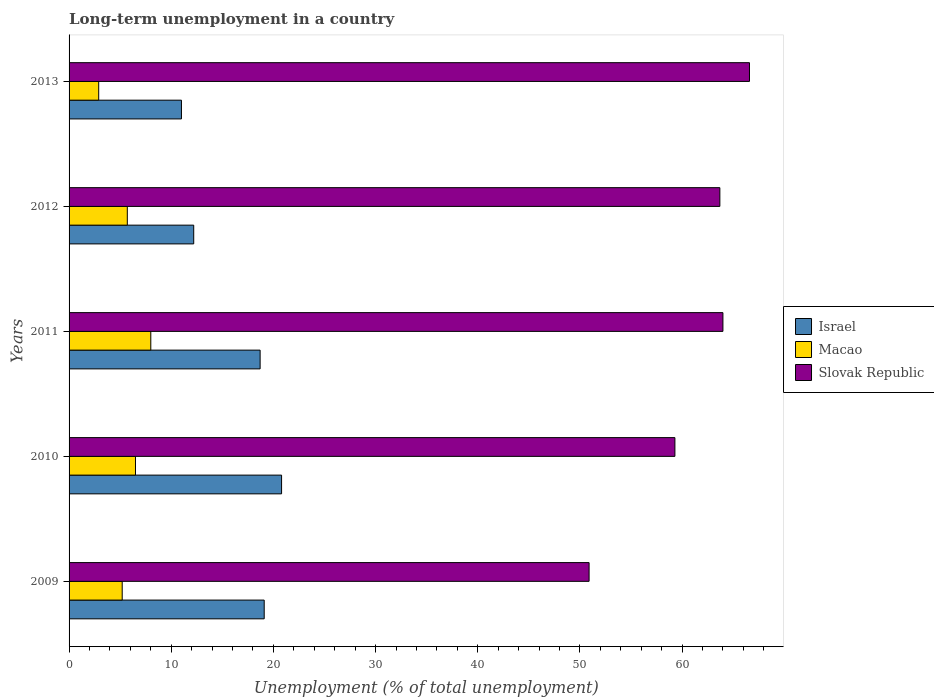How many different coloured bars are there?
Provide a succinct answer. 3. Are the number of bars per tick equal to the number of legend labels?
Your response must be concise. Yes. How many bars are there on the 3rd tick from the top?
Provide a succinct answer. 3. What is the label of the 4th group of bars from the top?
Your response must be concise. 2010. In how many cases, is the number of bars for a given year not equal to the number of legend labels?
Provide a succinct answer. 0. What is the percentage of long-term unemployed population in Israel in 2010?
Ensure brevity in your answer.  20.8. Across all years, what is the minimum percentage of long-term unemployed population in Macao?
Provide a short and direct response. 2.9. In which year was the percentage of long-term unemployed population in Slovak Republic maximum?
Give a very brief answer. 2013. In which year was the percentage of long-term unemployed population in Slovak Republic minimum?
Your answer should be very brief. 2009. What is the total percentage of long-term unemployed population in Slovak Republic in the graph?
Offer a very short reply. 304.5. What is the difference between the percentage of long-term unemployed population in Macao in 2010 and that in 2012?
Keep it short and to the point. 0.8. What is the difference between the percentage of long-term unemployed population in Macao in 2009 and the percentage of long-term unemployed population in Slovak Republic in 2013?
Your answer should be very brief. -61.4. What is the average percentage of long-term unemployed population in Macao per year?
Provide a succinct answer. 5.66. In the year 2012, what is the difference between the percentage of long-term unemployed population in Israel and percentage of long-term unemployed population in Macao?
Your response must be concise. 6.5. What is the ratio of the percentage of long-term unemployed population in Israel in 2011 to that in 2012?
Make the answer very short. 1.53. What is the difference between the highest and the second highest percentage of long-term unemployed population in Israel?
Offer a terse response. 1.7. What is the difference between the highest and the lowest percentage of long-term unemployed population in Slovak Republic?
Your response must be concise. 15.7. In how many years, is the percentage of long-term unemployed population in Slovak Republic greater than the average percentage of long-term unemployed population in Slovak Republic taken over all years?
Keep it short and to the point. 3. What does the 3rd bar from the bottom in 2012 represents?
Offer a terse response. Slovak Republic. Is it the case that in every year, the sum of the percentage of long-term unemployed population in Slovak Republic and percentage of long-term unemployed population in Israel is greater than the percentage of long-term unemployed population in Macao?
Ensure brevity in your answer.  Yes. Are all the bars in the graph horizontal?
Your answer should be compact. Yes. How many years are there in the graph?
Your answer should be very brief. 5. Does the graph contain any zero values?
Keep it short and to the point. No. Where does the legend appear in the graph?
Provide a short and direct response. Center right. How many legend labels are there?
Give a very brief answer. 3. What is the title of the graph?
Your answer should be very brief. Long-term unemployment in a country. Does "Czech Republic" appear as one of the legend labels in the graph?
Offer a very short reply. No. What is the label or title of the X-axis?
Provide a succinct answer. Unemployment (% of total unemployment). What is the label or title of the Y-axis?
Your response must be concise. Years. What is the Unemployment (% of total unemployment) in Israel in 2009?
Offer a very short reply. 19.1. What is the Unemployment (% of total unemployment) of Macao in 2009?
Your response must be concise. 5.2. What is the Unemployment (% of total unemployment) of Slovak Republic in 2009?
Offer a very short reply. 50.9. What is the Unemployment (% of total unemployment) in Israel in 2010?
Keep it short and to the point. 20.8. What is the Unemployment (% of total unemployment) in Slovak Republic in 2010?
Provide a short and direct response. 59.3. What is the Unemployment (% of total unemployment) in Israel in 2011?
Keep it short and to the point. 18.7. What is the Unemployment (% of total unemployment) in Macao in 2011?
Keep it short and to the point. 8. What is the Unemployment (% of total unemployment) of Slovak Republic in 2011?
Give a very brief answer. 64. What is the Unemployment (% of total unemployment) of Israel in 2012?
Your response must be concise. 12.2. What is the Unemployment (% of total unemployment) in Macao in 2012?
Provide a short and direct response. 5.7. What is the Unemployment (% of total unemployment) in Slovak Republic in 2012?
Keep it short and to the point. 63.7. What is the Unemployment (% of total unemployment) of Macao in 2013?
Keep it short and to the point. 2.9. What is the Unemployment (% of total unemployment) of Slovak Republic in 2013?
Make the answer very short. 66.6. Across all years, what is the maximum Unemployment (% of total unemployment) in Israel?
Provide a short and direct response. 20.8. Across all years, what is the maximum Unemployment (% of total unemployment) in Macao?
Provide a succinct answer. 8. Across all years, what is the maximum Unemployment (% of total unemployment) of Slovak Republic?
Offer a very short reply. 66.6. Across all years, what is the minimum Unemployment (% of total unemployment) of Macao?
Give a very brief answer. 2.9. Across all years, what is the minimum Unemployment (% of total unemployment) of Slovak Republic?
Ensure brevity in your answer.  50.9. What is the total Unemployment (% of total unemployment) of Israel in the graph?
Your answer should be very brief. 81.8. What is the total Unemployment (% of total unemployment) in Macao in the graph?
Offer a terse response. 28.3. What is the total Unemployment (% of total unemployment) of Slovak Republic in the graph?
Ensure brevity in your answer.  304.5. What is the difference between the Unemployment (% of total unemployment) of Macao in 2009 and that in 2010?
Ensure brevity in your answer.  -1.3. What is the difference between the Unemployment (% of total unemployment) in Slovak Republic in 2009 and that in 2010?
Ensure brevity in your answer.  -8.4. What is the difference between the Unemployment (% of total unemployment) in Macao in 2009 and that in 2011?
Keep it short and to the point. -2.8. What is the difference between the Unemployment (% of total unemployment) in Slovak Republic in 2009 and that in 2011?
Offer a terse response. -13.1. What is the difference between the Unemployment (% of total unemployment) in Israel in 2009 and that in 2012?
Provide a short and direct response. 6.9. What is the difference between the Unemployment (% of total unemployment) in Macao in 2009 and that in 2013?
Give a very brief answer. 2.3. What is the difference between the Unemployment (% of total unemployment) in Slovak Republic in 2009 and that in 2013?
Offer a terse response. -15.7. What is the difference between the Unemployment (% of total unemployment) in Macao in 2010 and that in 2011?
Make the answer very short. -1.5. What is the difference between the Unemployment (% of total unemployment) of Slovak Republic in 2010 and that in 2011?
Provide a short and direct response. -4.7. What is the difference between the Unemployment (% of total unemployment) of Slovak Republic in 2010 and that in 2012?
Keep it short and to the point. -4.4. What is the difference between the Unemployment (% of total unemployment) of Israel in 2011 and that in 2012?
Ensure brevity in your answer.  6.5. What is the difference between the Unemployment (% of total unemployment) of Israel in 2011 and that in 2013?
Give a very brief answer. 7.7. What is the difference between the Unemployment (% of total unemployment) in Macao in 2011 and that in 2013?
Offer a very short reply. 5.1. What is the difference between the Unemployment (% of total unemployment) of Slovak Republic in 2012 and that in 2013?
Offer a very short reply. -2.9. What is the difference between the Unemployment (% of total unemployment) in Israel in 2009 and the Unemployment (% of total unemployment) in Macao in 2010?
Provide a succinct answer. 12.6. What is the difference between the Unemployment (% of total unemployment) in Israel in 2009 and the Unemployment (% of total unemployment) in Slovak Republic in 2010?
Give a very brief answer. -40.2. What is the difference between the Unemployment (% of total unemployment) of Macao in 2009 and the Unemployment (% of total unemployment) of Slovak Republic in 2010?
Provide a succinct answer. -54.1. What is the difference between the Unemployment (% of total unemployment) of Israel in 2009 and the Unemployment (% of total unemployment) of Slovak Republic in 2011?
Offer a terse response. -44.9. What is the difference between the Unemployment (% of total unemployment) of Macao in 2009 and the Unemployment (% of total unemployment) of Slovak Republic in 2011?
Provide a succinct answer. -58.8. What is the difference between the Unemployment (% of total unemployment) in Israel in 2009 and the Unemployment (% of total unemployment) in Slovak Republic in 2012?
Give a very brief answer. -44.6. What is the difference between the Unemployment (% of total unemployment) in Macao in 2009 and the Unemployment (% of total unemployment) in Slovak Republic in 2012?
Your response must be concise. -58.5. What is the difference between the Unemployment (% of total unemployment) of Israel in 2009 and the Unemployment (% of total unemployment) of Macao in 2013?
Provide a short and direct response. 16.2. What is the difference between the Unemployment (% of total unemployment) in Israel in 2009 and the Unemployment (% of total unemployment) in Slovak Republic in 2013?
Provide a short and direct response. -47.5. What is the difference between the Unemployment (% of total unemployment) in Macao in 2009 and the Unemployment (% of total unemployment) in Slovak Republic in 2013?
Provide a short and direct response. -61.4. What is the difference between the Unemployment (% of total unemployment) of Israel in 2010 and the Unemployment (% of total unemployment) of Slovak Republic in 2011?
Ensure brevity in your answer.  -43.2. What is the difference between the Unemployment (% of total unemployment) in Macao in 2010 and the Unemployment (% of total unemployment) in Slovak Republic in 2011?
Provide a short and direct response. -57.5. What is the difference between the Unemployment (% of total unemployment) of Israel in 2010 and the Unemployment (% of total unemployment) of Slovak Republic in 2012?
Give a very brief answer. -42.9. What is the difference between the Unemployment (% of total unemployment) in Macao in 2010 and the Unemployment (% of total unemployment) in Slovak Republic in 2012?
Offer a terse response. -57.2. What is the difference between the Unemployment (% of total unemployment) of Israel in 2010 and the Unemployment (% of total unemployment) of Slovak Republic in 2013?
Ensure brevity in your answer.  -45.8. What is the difference between the Unemployment (% of total unemployment) of Macao in 2010 and the Unemployment (% of total unemployment) of Slovak Republic in 2013?
Offer a terse response. -60.1. What is the difference between the Unemployment (% of total unemployment) of Israel in 2011 and the Unemployment (% of total unemployment) of Slovak Republic in 2012?
Make the answer very short. -45. What is the difference between the Unemployment (% of total unemployment) in Macao in 2011 and the Unemployment (% of total unemployment) in Slovak Republic in 2012?
Provide a short and direct response. -55.7. What is the difference between the Unemployment (% of total unemployment) of Israel in 2011 and the Unemployment (% of total unemployment) of Macao in 2013?
Give a very brief answer. 15.8. What is the difference between the Unemployment (% of total unemployment) of Israel in 2011 and the Unemployment (% of total unemployment) of Slovak Republic in 2013?
Provide a succinct answer. -47.9. What is the difference between the Unemployment (% of total unemployment) in Macao in 2011 and the Unemployment (% of total unemployment) in Slovak Republic in 2013?
Provide a short and direct response. -58.6. What is the difference between the Unemployment (% of total unemployment) of Israel in 2012 and the Unemployment (% of total unemployment) of Macao in 2013?
Your answer should be very brief. 9.3. What is the difference between the Unemployment (% of total unemployment) in Israel in 2012 and the Unemployment (% of total unemployment) in Slovak Republic in 2013?
Offer a very short reply. -54.4. What is the difference between the Unemployment (% of total unemployment) in Macao in 2012 and the Unemployment (% of total unemployment) in Slovak Republic in 2013?
Provide a succinct answer. -60.9. What is the average Unemployment (% of total unemployment) of Israel per year?
Your answer should be compact. 16.36. What is the average Unemployment (% of total unemployment) of Macao per year?
Offer a very short reply. 5.66. What is the average Unemployment (% of total unemployment) in Slovak Republic per year?
Offer a very short reply. 60.9. In the year 2009, what is the difference between the Unemployment (% of total unemployment) of Israel and Unemployment (% of total unemployment) of Slovak Republic?
Your answer should be very brief. -31.8. In the year 2009, what is the difference between the Unemployment (% of total unemployment) in Macao and Unemployment (% of total unemployment) in Slovak Republic?
Give a very brief answer. -45.7. In the year 2010, what is the difference between the Unemployment (% of total unemployment) in Israel and Unemployment (% of total unemployment) in Slovak Republic?
Ensure brevity in your answer.  -38.5. In the year 2010, what is the difference between the Unemployment (% of total unemployment) of Macao and Unemployment (% of total unemployment) of Slovak Republic?
Offer a very short reply. -52.8. In the year 2011, what is the difference between the Unemployment (% of total unemployment) in Israel and Unemployment (% of total unemployment) in Macao?
Your answer should be compact. 10.7. In the year 2011, what is the difference between the Unemployment (% of total unemployment) of Israel and Unemployment (% of total unemployment) of Slovak Republic?
Keep it short and to the point. -45.3. In the year 2011, what is the difference between the Unemployment (% of total unemployment) in Macao and Unemployment (% of total unemployment) in Slovak Republic?
Keep it short and to the point. -56. In the year 2012, what is the difference between the Unemployment (% of total unemployment) in Israel and Unemployment (% of total unemployment) in Macao?
Offer a terse response. 6.5. In the year 2012, what is the difference between the Unemployment (% of total unemployment) in Israel and Unemployment (% of total unemployment) in Slovak Republic?
Make the answer very short. -51.5. In the year 2012, what is the difference between the Unemployment (% of total unemployment) of Macao and Unemployment (% of total unemployment) of Slovak Republic?
Provide a succinct answer. -58. In the year 2013, what is the difference between the Unemployment (% of total unemployment) of Israel and Unemployment (% of total unemployment) of Macao?
Provide a succinct answer. 8.1. In the year 2013, what is the difference between the Unemployment (% of total unemployment) in Israel and Unemployment (% of total unemployment) in Slovak Republic?
Make the answer very short. -55.6. In the year 2013, what is the difference between the Unemployment (% of total unemployment) of Macao and Unemployment (% of total unemployment) of Slovak Republic?
Your response must be concise. -63.7. What is the ratio of the Unemployment (% of total unemployment) in Israel in 2009 to that in 2010?
Offer a very short reply. 0.92. What is the ratio of the Unemployment (% of total unemployment) of Macao in 2009 to that in 2010?
Ensure brevity in your answer.  0.8. What is the ratio of the Unemployment (% of total unemployment) in Slovak Republic in 2009 to that in 2010?
Provide a short and direct response. 0.86. What is the ratio of the Unemployment (% of total unemployment) in Israel in 2009 to that in 2011?
Your answer should be compact. 1.02. What is the ratio of the Unemployment (% of total unemployment) in Macao in 2009 to that in 2011?
Your answer should be very brief. 0.65. What is the ratio of the Unemployment (% of total unemployment) in Slovak Republic in 2009 to that in 2011?
Ensure brevity in your answer.  0.8. What is the ratio of the Unemployment (% of total unemployment) in Israel in 2009 to that in 2012?
Make the answer very short. 1.57. What is the ratio of the Unemployment (% of total unemployment) of Macao in 2009 to that in 2012?
Provide a succinct answer. 0.91. What is the ratio of the Unemployment (% of total unemployment) of Slovak Republic in 2009 to that in 2012?
Provide a short and direct response. 0.8. What is the ratio of the Unemployment (% of total unemployment) of Israel in 2009 to that in 2013?
Make the answer very short. 1.74. What is the ratio of the Unemployment (% of total unemployment) of Macao in 2009 to that in 2013?
Your response must be concise. 1.79. What is the ratio of the Unemployment (% of total unemployment) of Slovak Republic in 2009 to that in 2013?
Give a very brief answer. 0.76. What is the ratio of the Unemployment (% of total unemployment) in Israel in 2010 to that in 2011?
Your answer should be very brief. 1.11. What is the ratio of the Unemployment (% of total unemployment) in Macao in 2010 to that in 2011?
Your response must be concise. 0.81. What is the ratio of the Unemployment (% of total unemployment) of Slovak Republic in 2010 to that in 2011?
Your answer should be very brief. 0.93. What is the ratio of the Unemployment (% of total unemployment) in Israel in 2010 to that in 2012?
Ensure brevity in your answer.  1.7. What is the ratio of the Unemployment (% of total unemployment) in Macao in 2010 to that in 2012?
Provide a succinct answer. 1.14. What is the ratio of the Unemployment (% of total unemployment) in Slovak Republic in 2010 to that in 2012?
Provide a short and direct response. 0.93. What is the ratio of the Unemployment (% of total unemployment) of Israel in 2010 to that in 2013?
Ensure brevity in your answer.  1.89. What is the ratio of the Unemployment (% of total unemployment) of Macao in 2010 to that in 2013?
Your response must be concise. 2.24. What is the ratio of the Unemployment (% of total unemployment) of Slovak Republic in 2010 to that in 2013?
Your answer should be very brief. 0.89. What is the ratio of the Unemployment (% of total unemployment) of Israel in 2011 to that in 2012?
Your answer should be compact. 1.53. What is the ratio of the Unemployment (% of total unemployment) of Macao in 2011 to that in 2012?
Your response must be concise. 1.4. What is the ratio of the Unemployment (% of total unemployment) in Slovak Republic in 2011 to that in 2012?
Your answer should be very brief. 1. What is the ratio of the Unemployment (% of total unemployment) of Israel in 2011 to that in 2013?
Give a very brief answer. 1.7. What is the ratio of the Unemployment (% of total unemployment) in Macao in 2011 to that in 2013?
Provide a succinct answer. 2.76. What is the ratio of the Unemployment (% of total unemployment) of Slovak Republic in 2011 to that in 2013?
Give a very brief answer. 0.96. What is the ratio of the Unemployment (% of total unemployment) of Israel in 2012 to that in 2013?
Provide a short and direct response. 1.11. What is the ratio of the Unemployment (% of total unemployment) in Macao in 2012 to that in 2013?
Keep it short and to the point. 1.97. What is the ratio of the Unemployment (% of total unemployment) in Slovak Republic in 2012 to that in 2013?
Provide a short and direct response. 0.96. What is the difference between the highest and the second highest Unemployment (% of total unemployment) of Israel?
Offer a terse response. 1.7. What is the difference between the highest and the second highest Unemployment (% of total unemployment) of Macao?
Ensure brevity in your answer.  1.5. What is the difference between the highest and the second highest Unemployment (% of total unemployment) of Slovak Republic?
Offer a very short reply. 2.6. What is the difference between the highest and the lowest Unemployment (% of total unemployment) of Macao?
Provide a short and direct response. 5.1. 